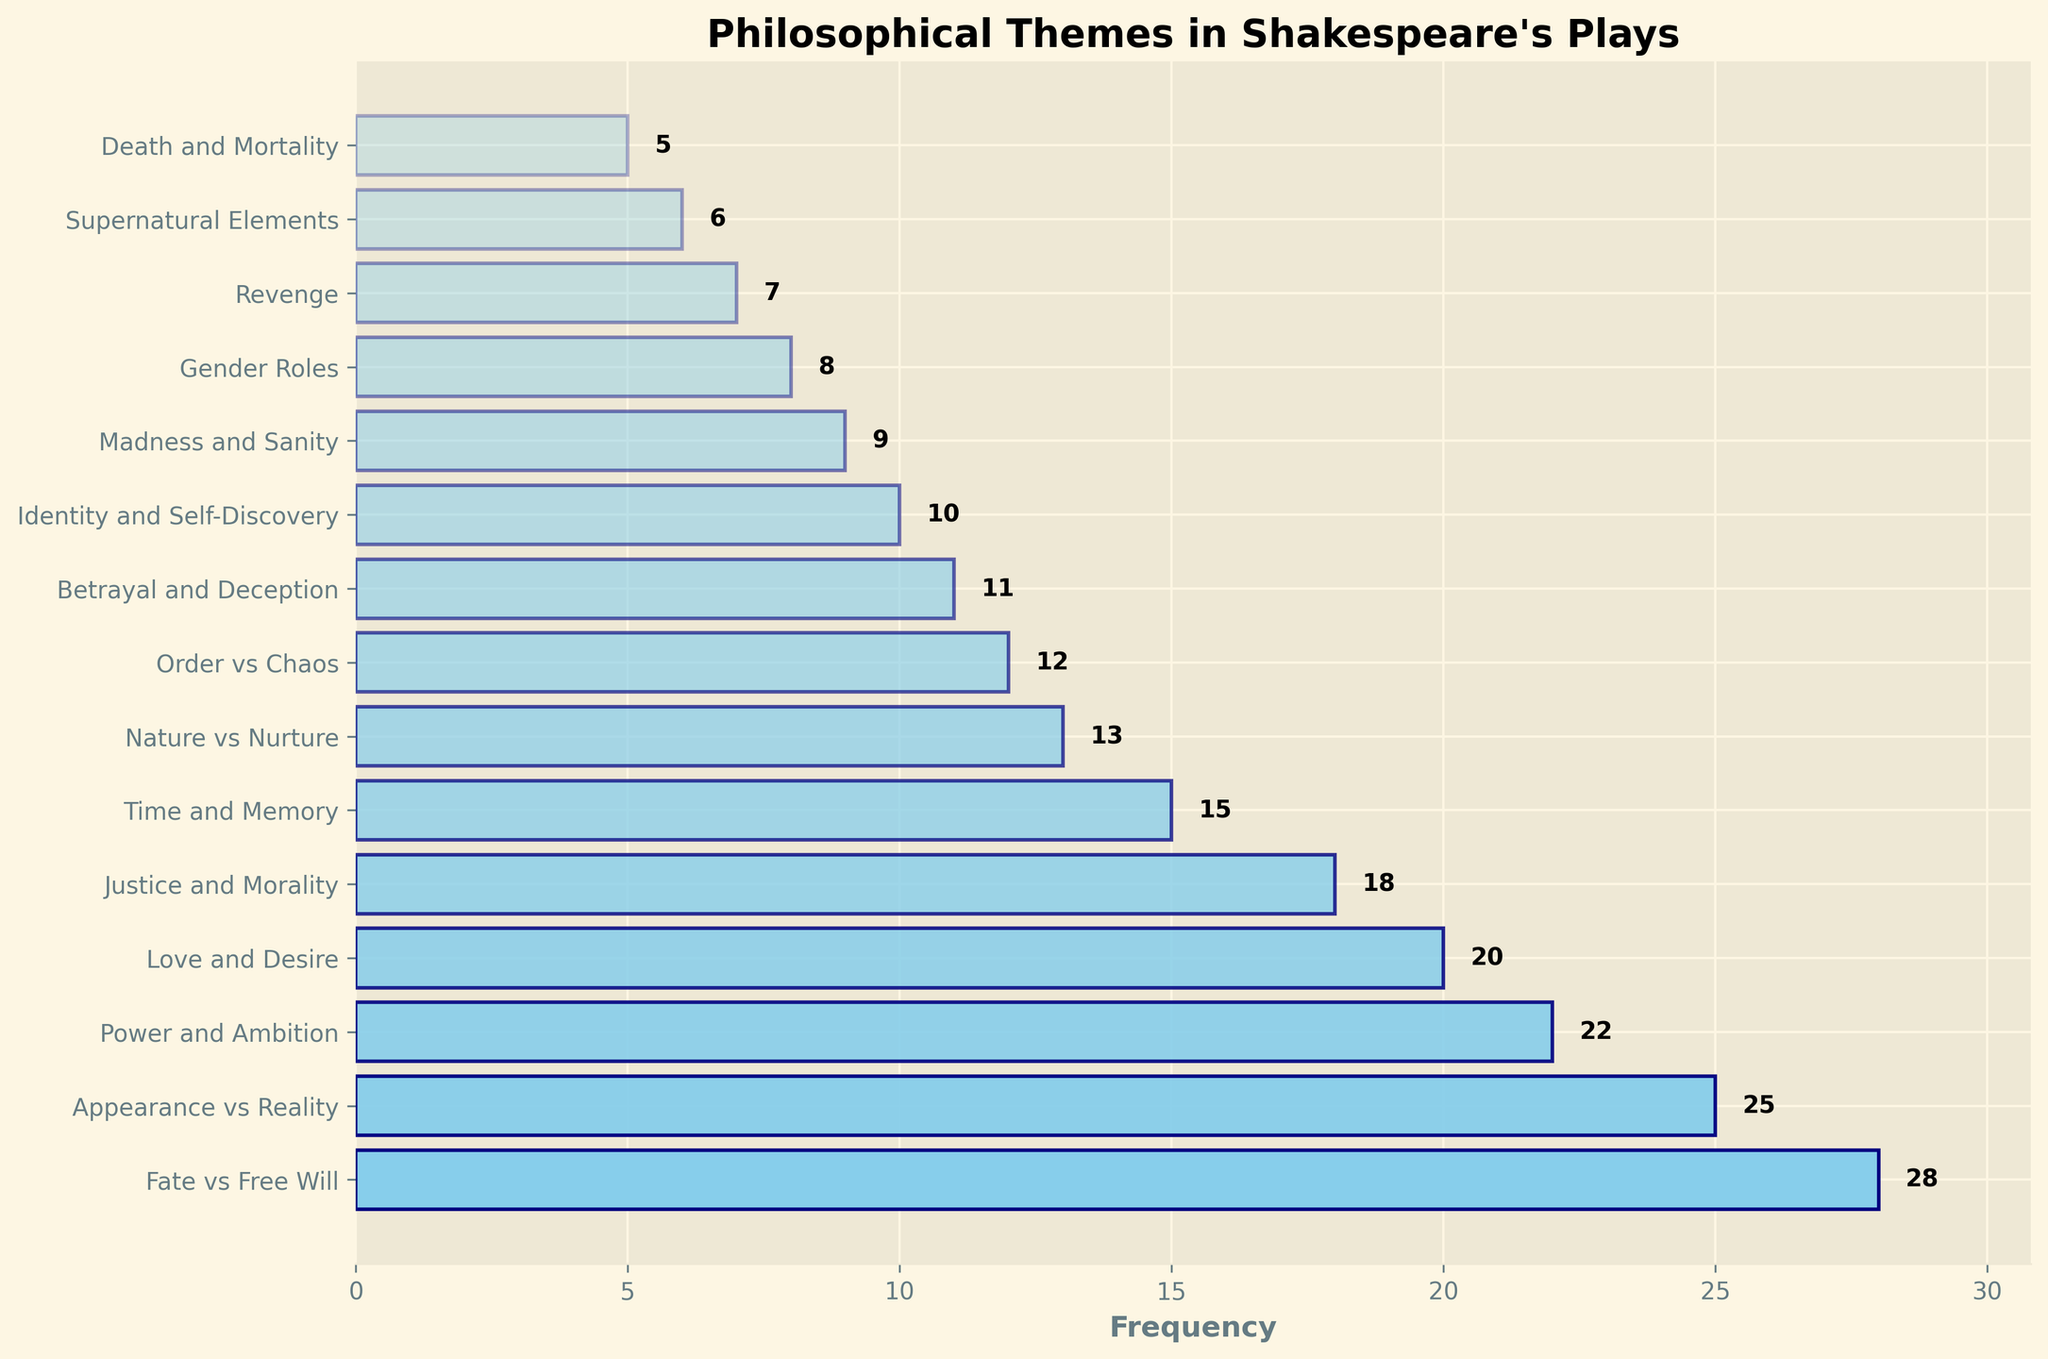What is the most frequently occurring philosophical theme in Shakespeare's plays? The theme with the highest frequency bar in the chart is "Fate vs Free Will" with a frequency of 28.
Answer: Fate vs Free Will How much more frequent is the theme "Appearance vs Reality" compared to "Revenge"? "Appearance vs Reality" has a frequency of 25, whereas "Revenge" has a frequency of 7. The difference is 25 - 7 = 18.
Answer: 18 What is the combined frequency of the themes "Power and Ambition" and "Love and Desire"? The frequency of "Power and Ambition" is 22, and the frequency of "Love and Desire" is 20. The combined frequency is 22 + 20 = 42.
Answer: 42 Which theme has a frequency that is closest to the median frequency of all themes? To find the median frequency, list all frequencies: [28, 25, 22, 20, 18, 15, 13, 12, 11, 10, 9, 8, 7, 6, 5]. The median value (middle one in the ordered list) is 13. The theme "Nature vs Nurture" has a frequency of 13, matching the median.
Answer: Nature vs Nurture Which two themes have the smallest difference in their frequencies? The smallest difference is between "Nature vs Nurture" (13) and "Order vs Chaos" (12), with a difference of 1.
Answer: Nature vs Nurture and Order vs Chaos How do the visual appearances (like color and height) of the bars for "Madness and Sanity" and "Gender Roles" compare? "Gender Roles" has a frequency of 8, and "Madness and Sanity" has a frequency of 9. The bar for "Madness and Sanity" is taller and slightly darker (due to the alpha setting) than the bar for "Gender Roles".
Answer: "Madness and Sanity" is taller and slightly darker than "Gender Roles" Which themes have frequencies lower than 10, and what is their combined frequency? The themes with frequencies lower than 10 are "Madness and Sanity" (9), "Gender Roles" (8), "Revenge" (7), "Supernatural Elements" (6), and "Death and Mortality" (5). Their combined frequency is 9 + 8 + 7 + 6 + 5 = 35.
Answer: Madness and Sanity, Gender Roles, Revenge, Supernatural Elements, Death and Mortality; 35 If the average frequency of the themes is used as a threshold, which themes have above-average frequencies? The total frequency is 230, and there are 15 themes. The average frequency is 230 / 15 ≈ 15.33. Themes with frequencies above this average are: "Fate vs Free Will" (28), "Appearance vs Reality" (25), "Power and Ambition" (22), "Love and Desire" (20), "Justice and Morality" (18), and "Time and Memory" (15) is slightly below the average so not considered above.
Answer: Fate vs Free Will, Appearance vs Reality, Power and Ambition, Love and Desire, Justice and Morality 